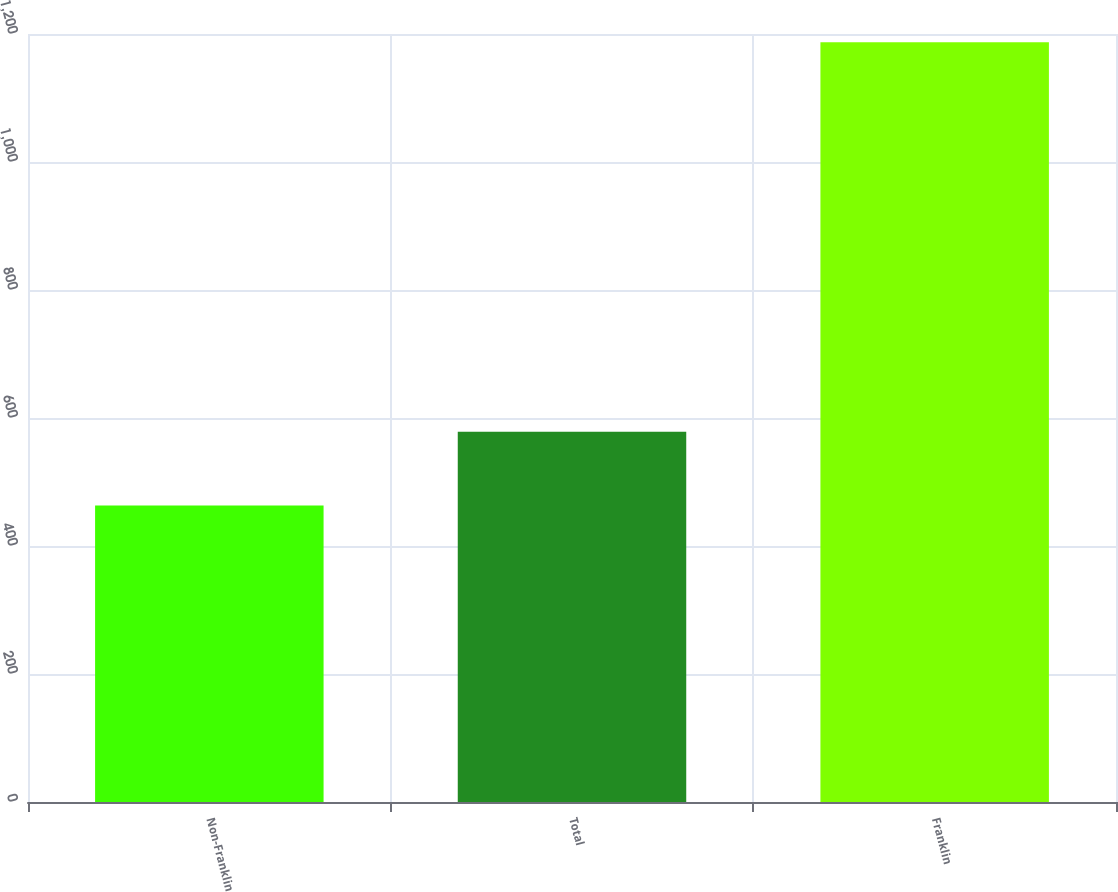Convert chart. <chart><loc_0><loc_0><loc_500><loc_500><bar_chart><fcel>Non-Franklin<fcel>Total<fcel>Franklin<nl><fcel>463.1<fcel>578.4<fcel>1187<nl></chart> 